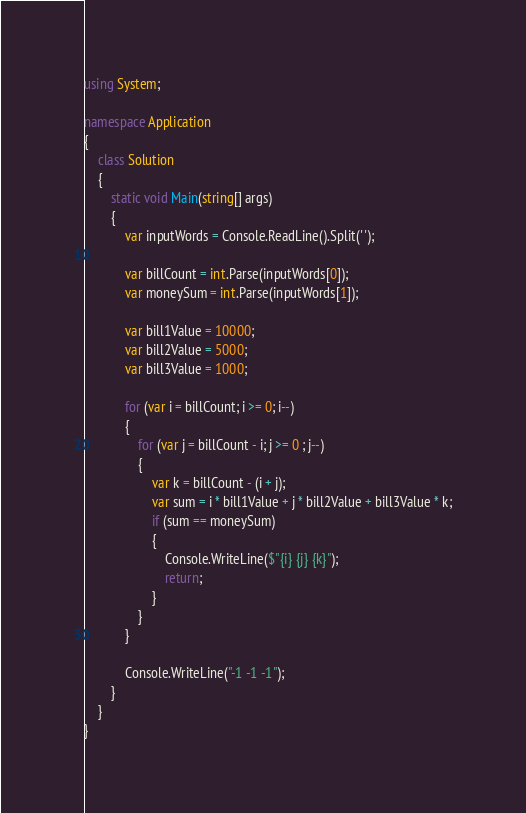Convert code to text. <code><loc_0><loc_0><loc_500><loc_500><_C#_>using System;
 
namespace Application
{
	class Solution
	{
		static void Main(string[] args)
		{
			var inputWords = Console.ReadLine().Split(' ');
 
			var billCount = int.Parse(inputWords[0]);
			var moneySum = int.Parse(inputWords[1]);
 
			var bill1Value = 10000;
			var bill2Value = 5000;
			var bill3Value = 1000;
 
			for (var i = billCount; i >= 0; i--)
			{
				for (var j = billCount - i; j >= 0 ; j--)
				{
					var k = billCount - (i + j);
					var sum = i * bill1Value + j * bill2Value + bill3Value * k;
					if (sum == moneySum)
					{
						Console.WriteLine($"{i} {j} {k}");
						return;
					}
				}
			}
 
			Console.WriteLine("-1 -1 -1");
		}
	}
}</code> 